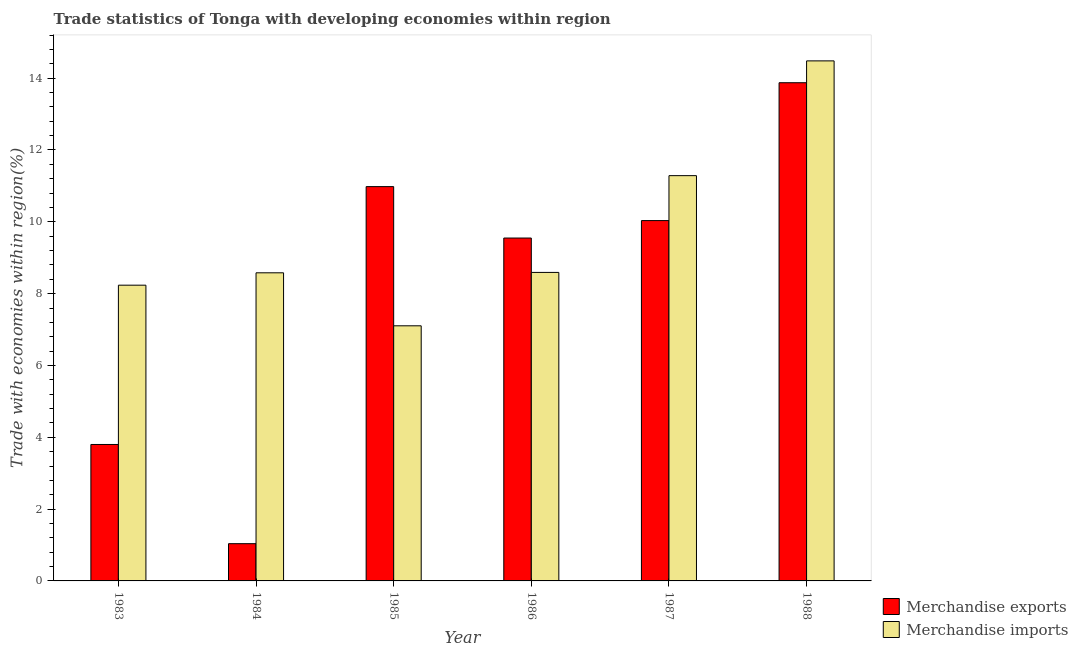How many groups of bars are there?
Give a very brief answer. 6. How many bars are there on the 4th tick from the left?
Offer a very short reply. 2. How many bars are there on the 4th tick from the right?
Your answer should be compact. 2. What is the label of the 3rd group of bars from the left?
Your response must be concise. 1985. What is the merchandise exports in 1984?
Your answer should be compact. 1.04. Across all years, what is the maximum merchandise imports?
Ensure brevity in your answer.  14.48. Across all years, what is the minimum merchandise exports?
Your answer should be very brief. 1.04. What is the total merchandise imports in the graph?
Make the answer very short. 58.28. What is the difference between the merchandise imports in 1986 and that in 1988?
Give a very brief answer. -5.89. What is the difference between the merchandise imports in 1985 and the merchandise exports in 1984?
Your response must be concise. -1.48. What is the average merchandise imports per year?
Your response must be concise. 9.71. In how many years, is the merchandise exports greater than 14.4 %?
Provide a succinct answer. 0. What is the ratio of the merchandise exports in 1983 to that in 1985?
Keep it short and to the point. 0.35. Is the merchandise imports in 1983 less than that in 1985?
Offer a very short reply. No. Is the difference between the merchandise exports in 1983 and 1985 greater than the difference between the merchandise imports in 1983 and 1985?
Provide a succinct answer. No. What is the difference between the highest and the second highest merchandise exports?
Keep it short and to the point. 2.89. What is the difference between the highest and the lowest merchandise exports?
Keep it short and to the point. 12.84. What does the 1st bar from the left in 1987 represents?
Give a very brief answer. Merchandise exports. What does the 1st bar from the right in 1988 represents?
Provide a short and direct response. Merchandise imports. Are all the bars in the graph horizontal?
Your response must be concise. No. How many years are there in the graph?
Provide a short and direct response. 6. Does the graph contain grids?
Make the answer very short. No. Where does the legend appear in the graph?
Your answer should be very brief. Bottom right. How are the legend labels stacked?
Your response must be concise. Vertical. What is the title of the graph?
Your answer should be compact. Trade statistics of Tonga with developing economies within region. Does "Register a property" appear as one of the legend labels in the graph?
Offer a very short reply. No. What is the label or title of the Y-axis?
Offer a terse response. Trade with economies within region(%). What is the Trade with economies within region(%) of Merchandise exports in 1983?
Your answer should be compact. 3.8. What is the Trade with economies within region(%) in Merchandise imports in 1983?
Your answer should be compact. 8.24. What is the Trade with economies within region(%) in Merchandise exports in 1984?
Ensure brevity in your answer.  1.04. What is the Trade with economies within region(%) in Merchandise imports in 1984?
Ensure brevity in your answer.  8.58. What is the Trade with economies within region(%) in Merchandise exports in 1985?
Ensure brevity in your answer.  10.98. What is the Trade with economies within region(%) of Merchandise imports in 1985?
Provide a short and direct response. 7.1. What is the Trade with economies within region(%) in Merchandise exports in 1986?
Keep it short and to the point. 9.55. What is the Trade with economies within region(%) in Merchandise imports in 1986?
Provide a short and direct response. 8.59. What is the Trade with economies within region(%) of Merchandise exports in 1987?
Give a very brief answer. 10.03. What is the Trade with economies within region(%) in Merchandise imports in 1987?
Your response must be concise. 11.29. What is the Trade with economies within region(%) of Merchandise exports in 1988?
Provide a succinct answer. 13.87. What is the Trade with economies within region(%) in Merchandise imports in 1988?
Provide a succinct answer. 14.48. Across all years, what is the maximum Trade with economies within region(%) in Merchandise exports?
Offer a very short reply. 13.87. Across all years, what is the maximum Trade with economies within region(%) in Merchandise imports?
Give a very brief answer. 14.48. Across all years, what is the minimum Trade with economies within region(%) of Merchandise exports?
Provide a short and direct response. 1.04. Across all years, what is the minimum Trade with economies within region(%) of Merchandise imports?
Offer a very short reply. 7.1. What is the total Trade with economies within region(%) in Merchandise exports in the graph?
Offer a very short reply. 49.27. What is the total Trade with economies within region(%) of Merchandise imports in the graph?
Your response must be concise. 58.28. What is the difference between the Trade with economies within region(%) of Merchandise exports in 1983 and that in 1984?
Provide a succinct answer. 2.76. What is the difference between the Trade with economies within region(%) of Merchandise imports in 1983 and that in 1984?
Provide a short and direct response. -0.34. What is the difference between the Trade with economies within region(%) in Merchandise exports in 1983 and that in 1985?
Make the answer very short. -7.18. What is the difference between the Trade with economies within region(%) of Merchandise imports in 1983 and that in 1985?
Offer a terse response. 1.13. What is the difference between the Trade with economies within region(%) of Merchandise exports in 1983 and that in 1986?
Provide a short and direct response. -5.75. What is the difference between the Trade with economies within region(%) of Merchandise imports in 1983 and that in 1986?
Offer a terse response. -0.36. What is the difference between the Trade with economies within region(%) in Merchandise exports in 1983 and that in 1987?
Offer a very short reply. -6.23. What is the difference between the Trade with economies within region(%) of Merchandise imports in 1983 and that in 1987?
Provide a short and direct response. -3.05. What is the difference between the Trade with economies within region(%) of Merchandise exports in 1983 and that in 1988?
Provide a short and direct response. -10.07. What is the difference between the Trade with economies within region(%) of Merchandise imports in 1983 and that in 1988?
Ensure brevity in your answer.  -6.25. What is the difference between the Trade with economies within region(%) of Merchandise exports in 1984 and that in 1985?
Offer a very short reply. -9.94. What is the difference between the Trade with economies within region(%) of Merchandise imports in 1984 and that in 1985?
Give a very brief answer. 1.48. What is the difference between the Trade with economies within region(%) in Merchandise exports in 1984 and that in 1986?
Provide a succinct answer. -8.51. What is the difference between the Trade with economies within region(%) in Merchandise imports in 1984 and that in 1986?
Provide a short and direct response. -0.01. What is the difference between the Trade with economies within region(%) in Merchandise exports in 1984 and that in 1987?
Give a very brief answer. -9. What is the difference between the Trade with economies within region(%) of Merchandise imports in 1984 and that in 1987?
Give a very brief answer. -2.71. What is the difference between the Trade with economies within region(%) in Merchandise exports in 1984 and that in 1988?
Make the answer very short. -12.84. What is the difference between the Trade with economies within region(%) in Merchandise imports in 1984 and that in 1988?
Your answer should be compact. -5.9. What is the difference between the Trade with economies within region(%) of Merchandise exports in 1985 and that in 1986?
Your answer should be compact. 1.43. What is the difference between the Trade with economies within region(%) in Merchandise imports in 1985 and that in 1986?
Give a very brief answer. -1.49. What is the difference between the Trade with economies within region(%) of Merchandise exports in 1985 and that in 1987?
Your answer should be compact. 0.95. What is the difference between the Trade with economies within region(%) in Merchandise imports in 1985 and that in 1987?
Ensure brevity in your answer.  -4.18. What is the difference between the Trade with economies within region(%) in Merchandise exports in 1985 and that in 1988?
Your answer should be compact. -2.89. What is the difference between the Trade with economies within region(%) in Merchandise imports in 1985 and that in 1988?
Make the answer very short. -7.38. What is the difference between the Trade with economies within region(%) in Merchandise exports in 1986 and that in 1987?
Offer a very short reply. -0.49. What is the difference between the Trade with economies within region(%) of Merchandise imports in 1986 and that in 1987?
Provide a succinct answer. -2.69. What is the difference between the Trade with economies within region(%) in Merchandise exports in 1986 and that in 1988?
Provide a succinct answer. -4.32. What is the difference between the Trade with economies within region(%) of Merchandise imports in 1986 and that in 1988?
Provide a succinct answer. -5.89. What is the difference between the Trade with economies within region(%) of Merchandise exports in 1987 and that in 1988?
Your answer should be very brief. -3.84. What is the difference between the Trade with economies within region(%) of Merchandise imports in 1987 and that in 1988?
Provide a short and direct response. -3.2. What is the difference between the Trade with economies within region(%) in Merchandise exports in 1983 and the Trade with economies within region(%) in Merchandise imports in 1984?
Your answer should be compact. -4.78. What is the difference between the Trade with economies within region(%) of Merchandise exports in 1983 and the Trade with economies within region(%) of Merchandise imports in 1985?
Offer a terse response. -3.3. What is the difference between the Trade with economies within region(%) in Merchandise exports in 1983 and the Trade with economies within region(%) in Merchandise imports in 1986?
Ensure brevity in your answer.  -4.79. What is the difference between the Trade with economies within region(%) of Merchandise exports in 1983 and the Trade with economies within region(%) of Merchandise imports in 1987?
Offer a very short reply. -7.49. What is the difference between the Trade with economies within region(%) in Merchandise exports in 1983 and the Trade with economies within region(%) in Merchandise imports in 1988?
Keep it short and to the point. -10.68. What is the difference between the Trade with economies within region(%) of Merchandise exports in 1984 and the Trade with economies within region(%) of Merchandise imports in 1985?
Provide a short and direct response. -6.07. What is the difference between the Trade with economies within region(%) of Merchandise exports in 1984 and the Trade with economies within region(%) of Merchandise imports in 1986?
Keep it short and to the point. -7.55. What is the difference between the Trade with economies within region(%) in Merchandise exports in 1984 and the Trade with economies within region(%) in Merchandise imports in 1987?
Give a very brief answer. -10.25. What is the difference between the Trade with economies within region(%) of Merchandise exports in 1984 and the Trade with economies within region(%) of Merchandise imports in 1988?
Keep it short and to the point. -13.44. What is the difference between the Trade with economies within region(%) in Merchandise exports in 1985 and the Trade with economies within region(%) in Merchandise imports in 1986?
Keep it short and to the point. 2.39. What is the difference between the Trade with economies within region(%) in Merchandise exports in 1985 and the Trade with economies within region(%) in Merchandise imports in 1987?
Offer a terse response. -0.31. What is the difference between the Trade with economies within region(%) of Merchandise exports in 1985 and the Trade with economies within region(%) of Merchandise imports in 1988?
Keep it short and to the point. -3.5. What is the difference between the Trade with economies within region(%) of Merchandise exports in 1986 and the Trade with economies within region(%) of Merchandise imports in 1987?
Make the answer very short. -1.74. What is the difference between the Trade with economies within region(%) of Merchandise exports in 1986 and the Trade with economies within region(%) of Merchandise imports in 1988?
Ensure brevity in your answer.  -4.93. What is the difference between the Trade with economies within region(%) in Merchandise exports in 1987 and the Trade with economies within region(%) in Merchandise imports in 1988?
Offer a terse response. -4.45. What is the average Trade with economies within region(%) of Merchandise exports per year?
Make the answer very short. 8.21. What is the average Trade with economies within region(%) of Merchandise imports per year?
Make the answer very short. 9.71. In the year 1983, what is the difference between the Trade with economies within region(%) of Merchandise exports and Trade with economies within region(%) of Merchandise imports?
Make the answer very short. -4.44. In the year 1984, what is the difference between the Trade with economies within region(%) of Merchandise exports and Trade with economies within region(%) of Merchandise imports?
Provide a short and direct response. -7.54. In the year 1985, what is the difference between the Trade with economies within region(%) of Merchandise exports and Trade with economies within region(%) of Merchandise imports?
Ensure brevity in your answer.  3.88. In the year 1986, what is the difference between the Trade with economies within region(%) in Merchandise exports and Trade with economies within region(%) in Merchandise imports?
Keep it short and to the point. 0.96. In the year 1987, what is the difference between the Trade with economies within region(%) of Merchandise exports and Trade with economies within region(%) of Merchandise imports?
Provide a short and direct response. -1.25. In the year 1988, what is the difference between the Trade with economies within region(%) of Merchandise exports and Trade with economies within region(%) of Merchandise imports?
Keep it short and to the point. -0.61. What is the ratio of the Trade with economies within region(%) of Merchandise exports in 1983 to that in 1984?
Ensure brevity in your answer.  3.66. What is the ratio of the Trade with economies within region(%) in Merchandise imports in 1983 to that in 1984?
Your answer should be very brief. 0.96. What is the ratio of the Trade with economies within region(%) in Merchandise exports in 1983 to that in 1985?
Provide a short and direct response. 0.35. What is the ratio of the Trade with economies within region(%) in Merchandise imports in 1983 to that in 1985?
Your answer should be very brief. 1.16. What is the ratio of the Trade with economies within region(%) in Merchandise exports in 1983 to that in 1986?
Keep it short and to the point. 0.4. What is the ratio of the Trade with economies within region(%) of Merchandise imports in 1983 to that in 1986?
Offer a terse response. 0.96. What is the ratio of the Trade with economies within region(%) of Merchandise exports in 1983 to that in 1987?
Offer a terse response. 0.38. What is the ratio of the Trade with economies within region(%) in Merchandise imports in 1983 to that in 1987?
Give a very brief answer. 0.73. What is the ratio of the Trade with economies within region(%) of Merchandise exports in 1983 to that in 1988?
Your response must be concise. 0.27. What is the ratio of the Trade with economies within region(%) of Merchandise imports in 1983 to that in 1988?
Give a very brief answer. 0.57. What is the ratio of the Trade with economies within region(%) in Merchandise exports in 1984 to that in 1985?
Provide a succinct answer. 0.09. What is the ratio of the Trade with economies within region(%) of Merchandise imports in 1984 to that in 1985?
Offer a very short reply. 1.21. What is the ratio of the Trade with economies within region(%) of Merchandise exports in 1984 to that in 1986?
Make the answer very short. 0.11. What is the ratio of the Trade with economies within region(%) of Merchandise imports in 1984 to that in 1986?
Your answer should be compact. 1. What is the ratio of the Trade with economies within region(%) of Merchandise exports in 1984 to that in 1987?
Keep it short and to the point. 0.1. What is the ratio of the Trade with economies within region(%) of Merchandise imports in 1984 to that in 1987?
Your answer should be compact. 0.76. What is the ratio of the Trade with economies within region(%) of Merchandise exports in 1984 to that in 1988?
Your answer should be very brief. 0.07. What is the ratio of the Trade with economies within region(%) in Merchandise imports in 1984 to that in 1988?
Keep it short and to the point. 0.59. What is the ratio of the Trade with economies within region(%) of Merchandise exports in 1985 to that in 1986?
Ensure brevity in your answer.  1.15. What is the ratio of the Trade with economies within region(%) of Merchandise imports in 1985 to that in 1986?
Your answer should be compact. 0.83. What is the ratio of the Trade with economies within region(%) of Merchandise exports in 1985 to that in 1987?
Ensure brevity in your answer.  1.09. What is the ratio of the Trade with economies within region(%) of Merchandise imports in 1985 to that in 1987?
Make the answer very short. 0.63. What is the ratio of the Trade with economies within region(%) in Merchandise exports in 1985 to that in 1988?
Offer a terse response. 0.79. What is the ratio of the Trade with economies within region(%) of Merchandise imports in 1985 to that in 1988?
Provide a short and direct response. 0.49. What is the ratio of the Trade with economies within region(%) of Merchandise exports in 1986 to that in 1987?
Offer a very short reply. 0.95. What is the ratio of the Trade with economies within region(%) in Merchandise imports in 1986 to that in 1987?
Your response must be concise. 0.76. What is the ratio of the Trade with economies within region(%) of Merchandise exports in 1986 to that in 1988?
Give a very brief answer. 0.69. What is the ratio of the Trade with economies within region(%) in Merchandise imports in 1986 to that in 1988?
Your answer should be compact. 0.59. What is the ratio of the Trade with economies within region(%) in Merchandise exports in 1987 to that in 1988?
Your response must be concise. 0.72. What is the ratio of the Trade with economies within region(%) in Merchandise imports in 1987 to that in 1988?
Keep it short and to the point. 0.78. What is the difference between the highest and the second highest Trade with economies within region(%) in Merchandise exports?
Offer a very short reply. 2.89. What is the difference between the highest and the second highest Trade with economies within region(%) in Merchandise imports?
Offer a terse response. 3.2. What is the difference between the highest and the lowest Trade with economies within region(%) of Merchandise exports?
Your response must be concise. 12.84. What is the difference between the highest and the lowest Trade with economies within region(%) in Merchandise imports?
Give a very brief answer. 7.38. 